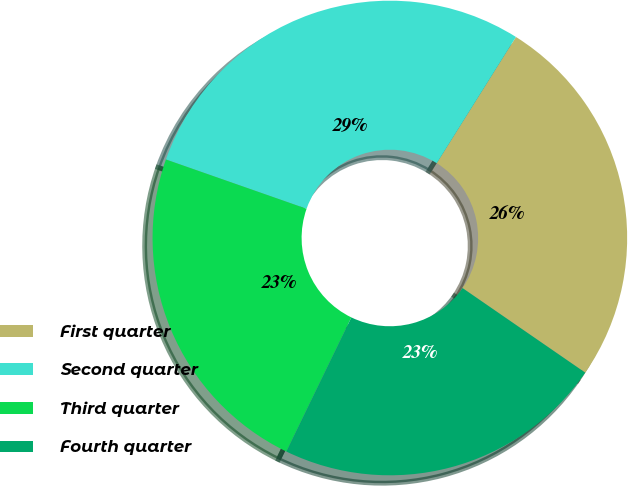Convert chart to OTSL. <chart><loc_0><loc_0><loc_500><loc_500><pie_chart><fcel>First quarter<fcel>Second quarter<fcel>Third quarter<fcel>Fourth quarter<nl><fcel>25.69%<fcel>28.55%<fcel>23.18%<fcel>22.58%<nl></chart> 